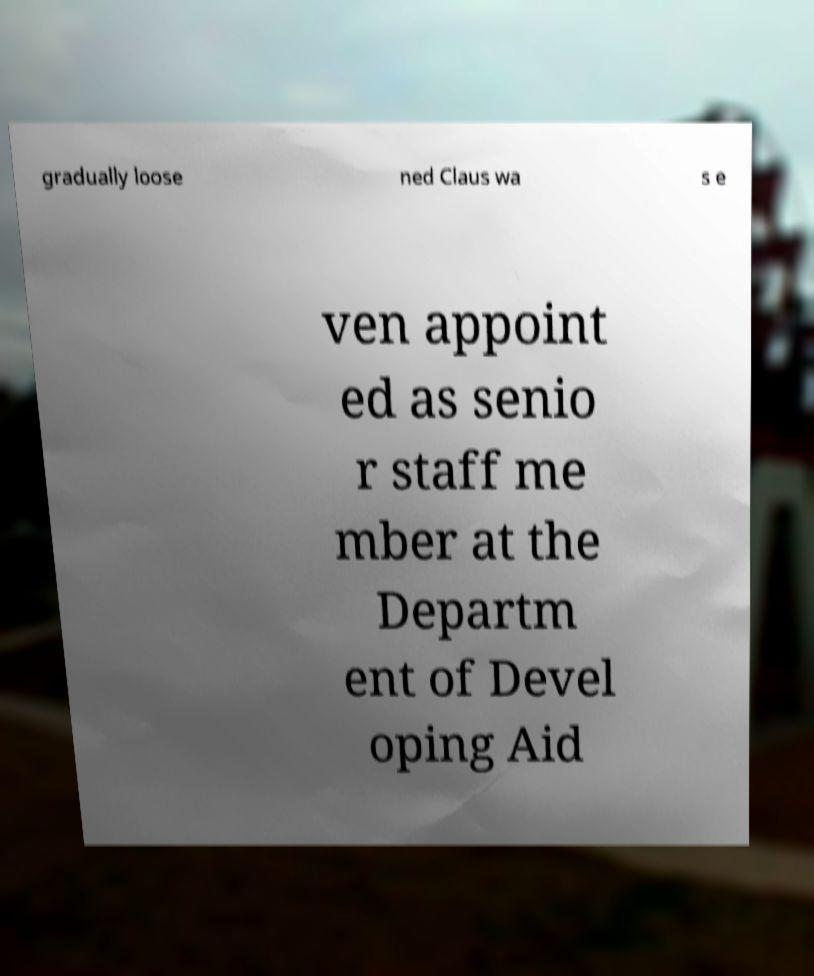I need the written content from this picture converted into text. Can you do that? gradually loose ned Claus wa s e ven appoint ed as senio r staff me mber at the Departm ent of Devel oping Aid 